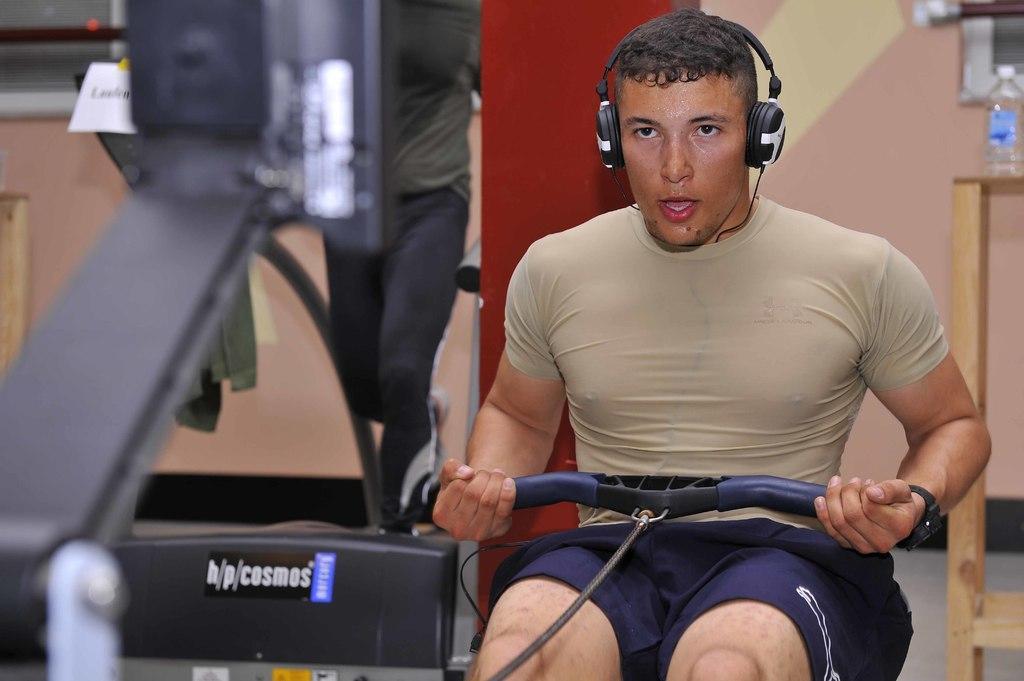Can you describe this image briefly? In this image I see a man who is holding a thing in his hands and I see that he is wearing a headphone on his head and I see that he is sitting and I see an equipment over here. In the background I see a bottle on this wooden thing and I see the wall and I can also see a person over here. 